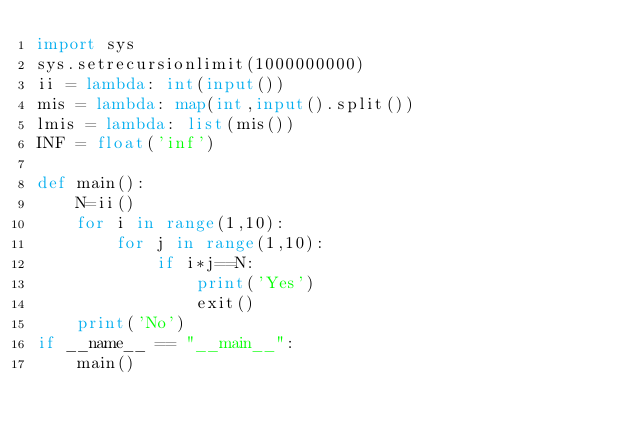<code> <loc_0><loc_0><loc_500><loc_500><_Python_>import sys
sys.setrecursionlimit(1000000000)
ii = lambda: int(input())
mis = lambda: map(int,input().split())
lmis = lambda: list(mis())
INF = float('inf')

def main():
    N=ii()
    for i in range(1,10):
        for j in range(1,10):
            if i*j==N:
                print('Yes')
                exit()
    print('No')
if __name__ == "__main__":
    main()</code> 